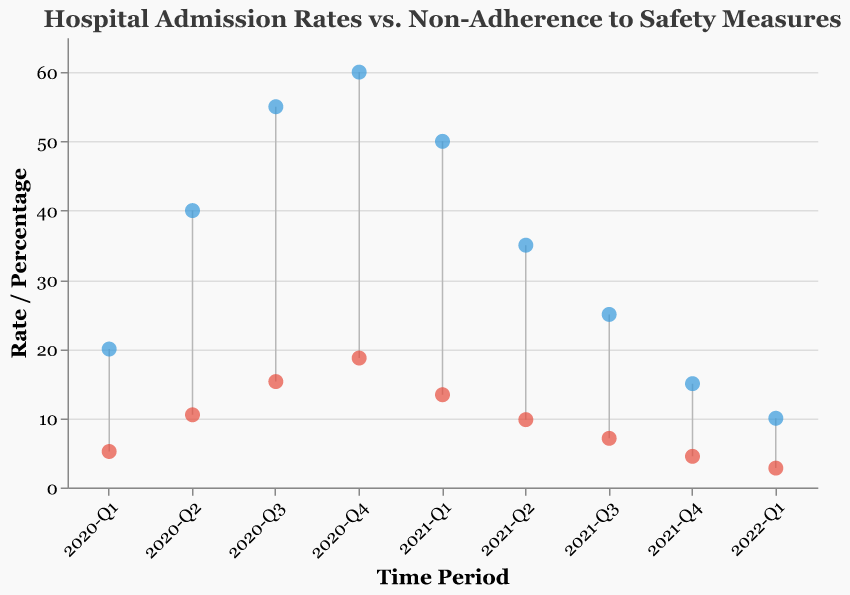How many time periods are represented in the figure? The figure covers each quarter from the beginning of 2020 (2020-Q1) to the first quarter of 2022 (2022-Q1). Counting these periods, there are a total of nine quarters.
Answer: Nine What does the red color represent in the plot? In the given Dumbbell Plot, red points represent the "Hospital Admission Rate" for Covid-19.
Answer: Hospital Admission Rate What is the trend in hospital admission rates from 2020-Q4 to 2022-Q1? The hospital admission rates decrease over the observed time periods from 18.7% in 2020-Q4 to 2.8% in 2022-Q1.
Answer: Decrease What is the highest non-adherence percentage shown in the figure, and in which time period does it occur? The highest non-adherence percentage is 60%, which occurs in 2020-Q4.
Answer: 60%, 2020-Q4 Compare the hospital admission rate and non-adherence percentage for the time period 2021-Q1. For 2021-Q1, the hospital admission rate is 13.4% and the non-adherence percentage is 50%.
Answer: 13.4%, 50% What is the difference between the non-adherence percentage and the hospital admission rate in 2021-Q2? In 2021-Q2, the non-adherence percentage is 35% and the hospital admission rate is 9.8%. The difference is 35% - 9.8% = 25.2%.
Answer: 25.2% How does the non-adherence percentage change from 2020-Q1 to 2020-Q4? The non-adherence percentage increases from 20% in 2020-Q1 to 60% in 2020-Q4.
Answer: Increase What is the longest duration over which hospital admission rates consistently decreased? Hospital admission rates decreased consistently from 2020-Q4 (18.7%) to 2022-Q1 (2.8%) which is a period across five quarters.
Answer: Five quarters In which time period do both hospital admission rates and non-adherence percentages decrease compared to the previous quarter? In 2021-Q2, both hospital admission rates (9.8%) and non-adherence percentages (35%) decreased compared to 2021-Q1 (13.4% and 50%, respectively).
Answer: 2021-Q2 